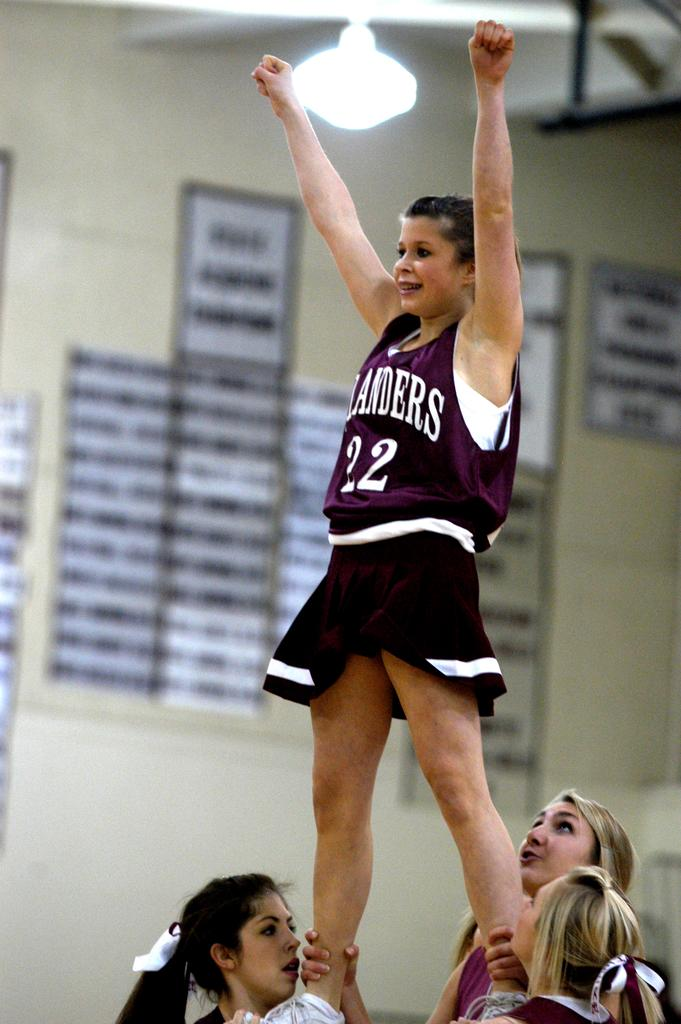<image>
Write a terse but informative summary of the picture. A cheerleader wearing jersey number 22 is lifted by other cheerleaders. 